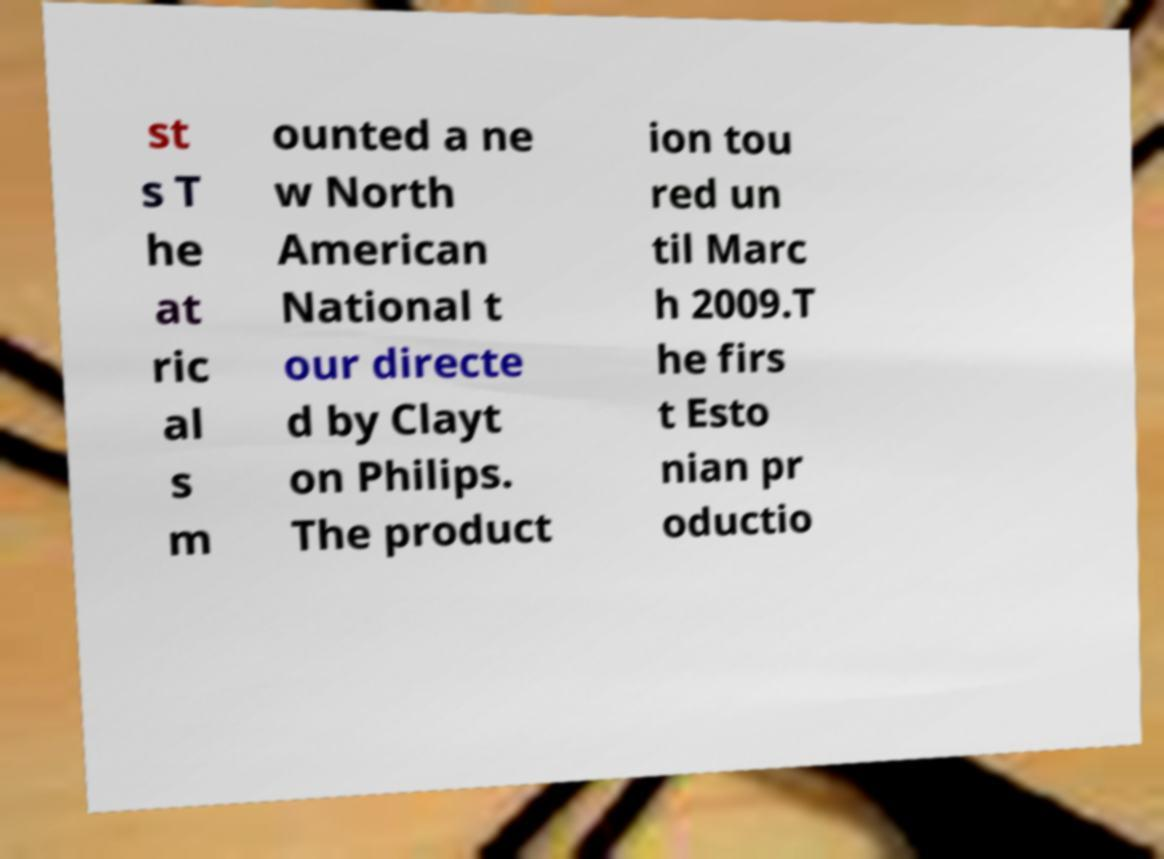Can you read and provide the text displayed in the image?This photo seems to have some interesting text. Can you extract and type it out for me? st s T he at ric al s m ounted a ne w North American National t our directe d by Clayt on Philips. The product ion tou red un til Marc h 2009.T he firs t Esto nian pr oductio 